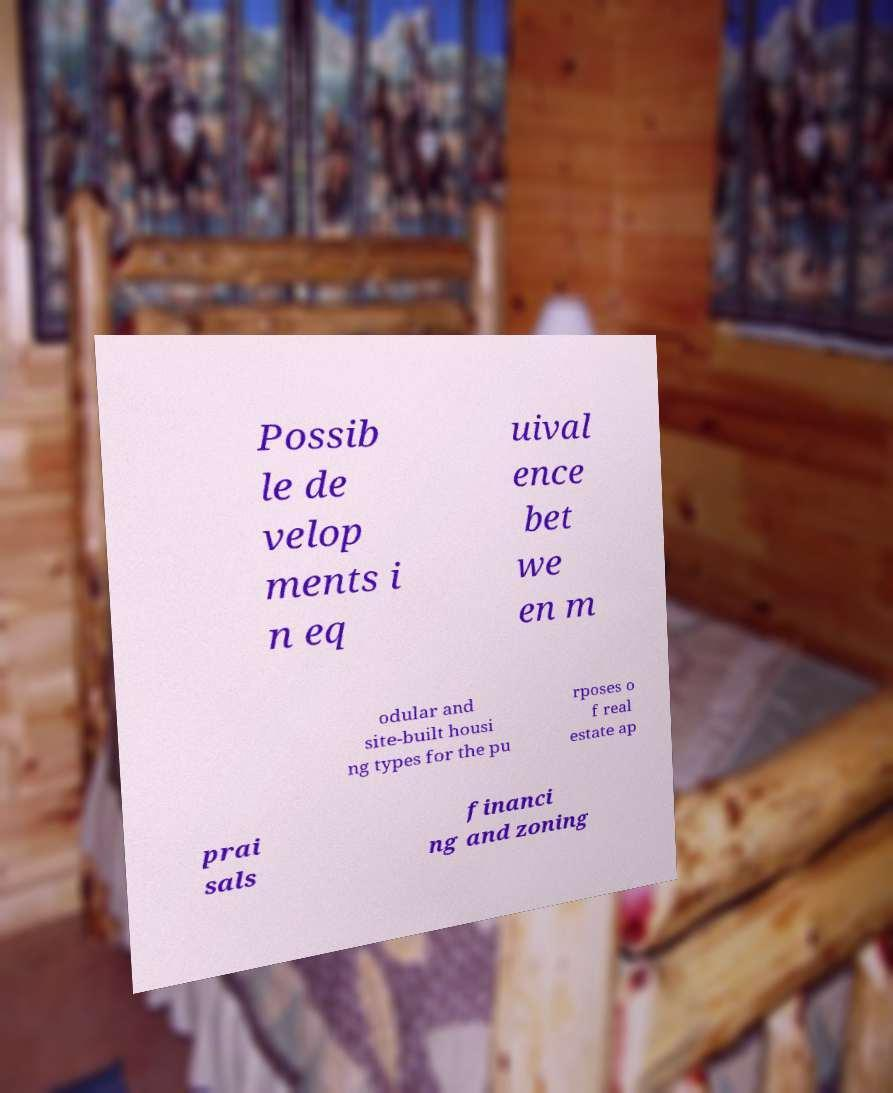Could you extract and type out the text from this image? Possib le de velop ments i n eq uival ence bet we en m odular and site-built housi ng types for the pu rposes o f real estate ap prai sals financi ng and zoning 